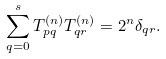Convert formula to latex. <formula><loc_0><loc_0><loc_500><loc_500>\sum _ { q = 0 } ^ { s } T ^ { ( n ) } _ { p q } T ^ { ( n ) } _ { q r } = 2 ^ { n } \delta _ { q r } .</formula> 